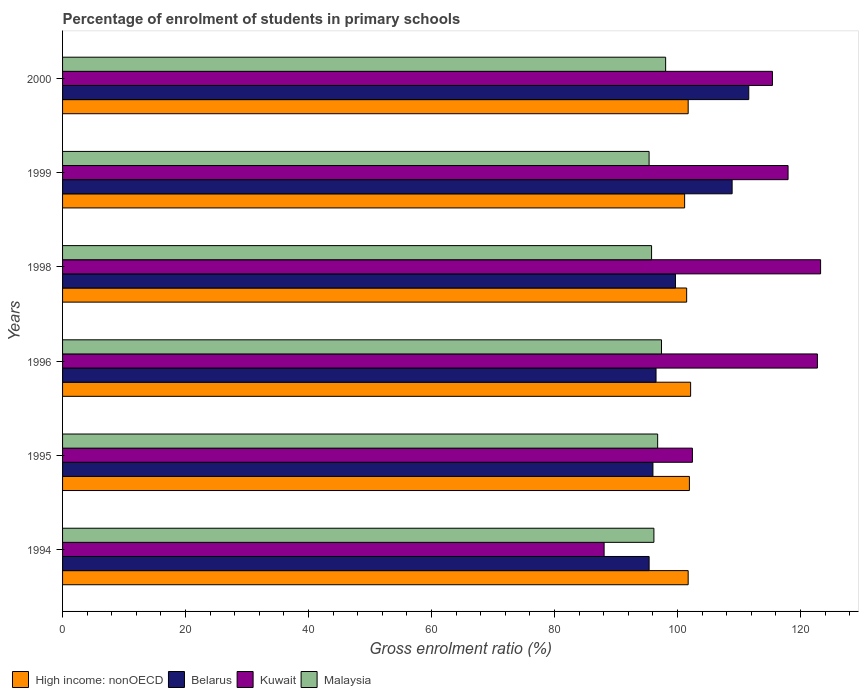How many groups of bars are there?
Your response must be concise. 6. Are the number of bars per tick equal to the number of legend labels?
Make the answer very short. Yes. Are the number of bars on each tick of the Y-axis equal?
Offer a very short reply. Yes. How many bars are there on the 3rd tick from the top?
Your answer should be very brief. 4. What is the label of the 1st group of bars from the top?
Keep it short and to the point. 2000. What is the percentage of students enrolled in primary schools in Malaysia in 1995?
Offer a very short reply. 96.78. Across all years, what is the maximum percentage of students enrolled in primary schools in Kuwait?
Provide a succinct answer. 123.28. Across all years, what is the minimum percentage of students enrolled in primary schools in High income: nonOECD?
Give a very brief answer. 101.16. What is the total percentage of students enrolled in primary schools in Belarus in the graph?
Your answer should be compact. 608.08. What is the difference between the percentage of students enrolled in primary schools in Belarus in 1996 and that in 1998?
Ensure brevity in your answer.  -3.16. What is the difference between the percentage of students enrolled in primary schools in Belarus in 1994 and the percentage of students enrolled in primary schools in Kuwait in 2000?
Your answer should be very brief. -20.05. What is the average percentage of students enrolled in primary schools in Belarus per year?
Offer a very short reply. 101.35. In the year 2000, what is the difference between the percentage of students enrolled in primary schools in High income: nonOECD and percentage of students enrolled in primary schools in Kuwait?
Ensure brevity in your answer.  -13.7. In how many years, is the percentage of students enrolled in primary schools in Malaysia greater than 80 %?
Your response must be concise. 6. What is the ratio of the percentage of students enrolled in primary schools in Belarus in 1998 to that in 1999?
Offer a terse response. 0.92. Is the percentage of students enrolled in primary schools in Malaysia in 1998 less than that in 2000?
Your answer should be compact. Yes. What is the difference between the highest and the second highest percentage of students enrolled in primary schools in Malaysia?
Provide a succinct answer. 0.67. What is the difference between the highest and the lowest percentage of students enrolled in primary schools in Kuwait?
Your answer should be compact. 35.21. In how many years, is the percentage of students enrolled in primary schools in Belarus greater than the average percentage of students enrolled in primary schools in Belarus taken over all years?
Offer a very short reply. 2. Is the sum of the percentage of students enrolled in primary schools in Kuwait in 1994 and 1995 greater than the maximum percentage of students enrolled in primary schools in Belarus across all years?
Your answer should be very brief. Yes. Is it the case that in every year, the sum of the percentage of students enrolled in primary schools in Malaysia and percentage of students enrolled in primary schools in Belarus is greater than the sum of percentage of students enrolled in primary schools in Kuwait and percentage of students enrolled in primary schools in High income: nonOECD?
Make the answer very short. No. What does the 3rd bar from the top in 1994 represents?
Provide a succinct answer. Belarus. What does the 4th bar from the bottom in 1998 represents?
Your answer should be compact. Malaysia. How many bars are there?
Make the answer very short. 24. How many years are there in the graph?
Provide a short and direct response. 6. Does the graph contain any zero values?
Give a very brief answer. No. Does the graph contain grids?
Make the answer very short. No. What is the title of the graph?
Ensure brevity in your answer.  Percentage of enrolment of students in primary schools. What is the label or title of the Y-axis?
Offer a terse response. Years. What is the Gross enrolment ratio (%) in High income: nonOECD in 1994?
Give a very brief answer. 101.74. What is the Gross enrolment ratio (%) in Belarus in 1994?
Offer a very short reply. 95.39. What is the Gross enrolment ratio (%) in Kuwait in 1994?
Ensure brevity in your answer.  88.07. What is the Gross enrolment ratio (%) of Malaysia in 1994?
Offer a terse response. 96.17. What is the Gross enrolment ratio (%) of High income: nonOECD in 1995?
Offer a very short reply. 101.94. What is the Gross enrolment ratio (%) of Belarus in 1995?
Offer a terse response. 96.01. What is the Gross enrolment ratio (%) in Kuwait in 1995?
Your answer should be very brief. 102.43. What is the Gross enrolment ratio (%) of Malaysia in 1995?
Your answer should be compact. 96.78. What is the Gross enrolment ratio (%) in High income: nonOECD in 1996?
Provide a succinct answer. 102.14. What is the Gross enrolment ratio (%) in Belarus in 1996?
Offer a terse response. 96.51. What is the Gross enrolment ratio (%) of Kuwait in 1996?
Your answer should be very brief. 122.76. What is the Gross enrolment ratio (%) of Malaysia in 1996?
Ensure brevity in your answer.  97.4. What is the Gross enrolment ratio (%) in High income: nonOECD in 1998?
Your answer should be compact. 101.5. What is the Gross enrolment ratio (%) of Belarus in 1998?
Your answer should be very brief. 99.68. What is the Gross enrolment ratio (%) of Kuwait in 1998?
Give a very brief answer. 123.28. What is the Gross enrolment ratio (%) of Malaysia in 1998?
Your response must be concise. 95.79. What is the Gross enrolment ratio (%) in High income: nonOECD in 1999?
Your answer should be compact. 101.16. What is the Gross enrolment ratio (%) of Belarus in 1999?
Your response must be concise. 108.89. What is the Gross enrolment ratio (%) of Kuwait in 1999?
Provide a short and direct response. 117.99. What is the Gross enrolment ratio (%) of Malaysia in 1999?
Your answer should be very brief. 95.39. What is the Gross enrolment ratio (%) of High income: nonOECD in 2000?
Offer a very short reply. 101.74. What is the Gross enrolment ratio (%) of Belarus in 2000?
Your answer should be compact. 111.6. What is the Gross enrolment ratio (%) of Kuwait in 2000?
Provide a short and direct response. 115.45. What is the Gross enrolment ratio (%) in Malaysia in 2000?
Provide a succinct answer. 98.08. Across all years, what is the maximum Gross enrolment ratio (%) of High income: nonOECD?
Ensure brevity in your answer.  102.14. Across all years, what is the maximum Gross enrolment ratio (%) in Belarus?
Offer a very short reply. 111.6. Across all years, what is the maximum Gross enrolment ratio (%) in Kuwait?
Offer a terse response. 123.28. Across all years, what is the maximum Gross enrolment ratio (%) in Malaysia?
Keep it short and to the point. 98.08. Across all years, what is the minimum Gross enrolment ratio (%) in High income: nonOECD?
Ensure brevity in your answer.  101.16. Across all years, what is the minimum Gross enrolment ratio (%) in Belarus?
Give a very brief answer. 95.39. Across all years, what is the minimum Gross enrolment ratio (%) in Kuwait?
Your answer should be compact. 88.07. Across all years, what is the minimum Gross enrolment ratio (%) of Malaysia?
Provide a succinct answer. 95.39. What is the total Gross enrolment ratio (%) of High income: nonOECD in the graph?
Provide a short and direct response. 610.23. What is the total Gross enrolment ratio (%) in Belarus in the graph?
Your answer should be very brief. 608.08. What is the total Gross enrolment ratio (%) in Kuwait in the graph?
Your answer should be very brief. 669.97. What is the total Gross enrolment ratio (%) of Malaysia in the graph?
Give a very brief answer. 579.6. What is the difference between the Gross enrolment ratio (%) in High income: nonOECD in 1994 and that in 1995?
Offer a very short reply. -0.2. What is the difference between the Gross enrolment ratio (%) in Belarus in 1994 and that in 1995?
Ensure brevity in your answer.  -0.62. What is the difference between the Gross enrolment ratio (%) of Kuwait in 1994 and that in 1995?
Your response must be concise. -14.36. What is the difference between the Gross enrolment ratio (%) in Malaysia in 1994 and that in 1995?
Give a very brief answer. -0.61. What is the difference between the Gross enrolment ratio (%) of High income: nonOECD in 1994 and that in 1996?
Provide a short and direct response. -0.4. What is the difference between the Gross enrolment ratio (%) in Belarus in 1994 and that in 1996?
Provide a short and direct response. -1.12. What is the difference between the Gross enrolment ratio (%) in Kuwait in 1994 and that in 1996?
Offer a very short reply. -34.69. What is the difference between the Gross enrolment ratio (%) in Malaysia in 1994 and that in 1996?
Provide a succinct answer. -1.23. What is the difference between the Gross enrolment ratio (%) in High income: nonOECD in 1994 and that in 1998?
Provide a short and direct response. 0.25. What is the difference between the Gross enrolment ratio (%) in Belarus in 1994 and that in 1998?
Your response must be concise. -4.29. What is the difference between the Gross enrolment ratio (%) in Kuwait in 1994 and that in 1998?
Provide a succinct answer. -35.21. What is the difference between the Gross enrolment ratio (%) of Malaysia in 1994 and that in 1998?
Offer a very short reply. 0.38. What is the difference between the Gross enrolment ratio (%) in High income: nonOECD in 1994 and that in 1999?
Your answer should be compact. 0.58. What is the difference between the Gross enrolment ratio (%) in Belarus in 1994 and that in 1999?
Your answer should be compact. -13.5. What is the difference between the Gross enrolment ratio (%) of Kuwait in 1994 and that in 1999?
Your response must be concise. -29.92. What is the difference between the Gross enrolment ratio (%) in Malaysia in 1994 and that in 1999?
Offer a very short reply. 0.78. What is the difference between the Gross enrolment ratio (%) in High income: nonOECD in 1994 and that in 2000?
Provide a short and direct response. 0. What is the difference between the Gross enrolment ratio (%) in Belarus in 1994 and that in 2000?
Offer a very short reply. -16.2. What is the difference between the Gross enrolment ratio (%) in Kuwait in 1994 and that in 2000?
Give a very brief answer. -27.38. What is the difference between the Gross enrolment ratio (%) of Malaysia in 1994 and that in 2000?
Your answer should be compact. -1.91. What is the difference between the Gross enrolment ratio (%) in High income: nonOECD in 1995 and that in 1996?
Offer a terse response. -0.2. What is the difference between the Gross enrolment ratio (%) in Belarus in 1995 and that in 1996?
Ensure brevity in your answer.  -0.5. What is the difference between the Gross enrolment ratio (%) of Kuwait in 1995 and that in 1996?
Provide a short and direct response. -20.33. What is the difference between the Gross enrolment ratio (%) of Malaysia in 1995 and that in 1996?
Your response must be concise. -0.62. What is the difference between the Gross enrolment ratio (%) in High income: nonOECD in 1995 and that in 1998?
Your response must be concise. 0.45. What is the difference between the Gross enrolment ratio (%) of Belarus in 1995 and that in 1998?
Give a very brief answer. -3.67. What is the difference between the Gross enrolment ratio (%) in Kuwait in 1995 and that in 1998?
Give a very brief answer. -20.85. What is the difference between the Gross enrolment ratio (%) in Malaysia in 1995 and that in 1998?
Keep it short and to the point. 0.99. What is the difference between the Gross enrolment ratio (%) of High income: nonOECD in 1995 and that in 1999?
Give a very brief answer. 0.78. What is the difference between the Gross enrolment ratio (%) in Belarus in 1995 and that in 1999?
Offer a very short reply. -12.88. What is the difference between the Gross enrolment ratio (%) of Kuwait in 1995 and that in 1999?
Offer a very short reply. -15.56. What is the difference between the Gross enrolment ratio (%) of Malaysia in 1995 and that in 1999?
Offer a very short reply. 1.39. What is the difference between the Gross enrolment ratio (%) of High income: nonOECD in 1995 and that in 2000?
Make the answer very short. 0.2. What is the difference between the Gross enrolment ratio (%) of Belarus in 1995 and that in 2000?
Offer a terse response. -15.58. What is the difference between the Gross enrolment ratio (%) of Kuwait in 1995 and that in 2000?
Keep it short and to the point. -13.01. What is the difference between the Gross enrolment ratio (%) in Malaysia in 1995 and that in 2000?
Provide a succinct answer. -1.3. What is the difference between the Gross enrolment ratio (%) of High income: nonOECD in 1996 and that in 1998?
Your answer should be very brief. 0.65. What is the difference between the Gross enrolment ratio (%) of Belarus in 1996 and that in 1998?
Make the answer very short. -3.16. What is the difference between the Gross enrolment ratio (%) in Kuwait in 1996 and that in 1998?
Give a very brief answer. -0.52. What is the difference between the Gross enrolment ratio (%) of Malaysia in 1996 and that in 1998?
Provide a succinct answer. 1.61. What is the difference between the Gross enrolment ratio (%) in High income: nonOECD in 1996 and that in 1999?
Provide a succinct answer. 0.98. What is the difference between the Gross enrolment ratio (%) of Belarus in 1996 and that in 1999?
Offer a terse response. -12.38. What is the difference between the Gross enrolment ratio (%) of Kuwait in 1996 and that in 1999?
Give a very brief answer. 4.77. What is the difference between the Gross enrolment ratio (%) in Malaysia in 1996 and that in 1999?
Ensure brevity in your answer.  2.02. What is the difference between the Gross enrolment ratio (%) of High income: nonOECD in 1996 and that in 2000?
Offer a very short reply. 0.4. What is the difference between the Gross enrolment ratio (%) of Belarus in 1996 and that in 2000?
Ensure brevity in your answer.  -15.08. What is the difference between the Gross enrolment ratio (%) of Kuwait in 1996 and that in 2000?
Offer a very short reply. 7.31. What is the difference between the Gross enrolment ratio (%) of Malaysia in 1996 and that in 2000?
Provide a succinct answer. -0.67. What is the difference between the Gross enrolment ratio (%) in High income: nonOECD in 1998 and that in 1999?
Ensure brevity in your answer.  0.33. What is the difference between the Gross enrolment ratio (%) of Belarus in 1998 and that in 1999?
Your response must be concise. -9.21. What is the difference between the Gross enrolment ratio (%) of Kuwait in 1998 and that in 1999?
Provide a short and direct response. 5.29. What is the difference between the Gross enrolment ratio (%) in Malaysia in 1998 and that in 1999?
Offer a terse response. 0.4. What is the difference between the Gross enrolment ratio (%) in High income: nonOECD in 1998 and that in 2000?
Your response must be concise. -0.25. What is the difference between the Gross enrolment ratio (%) of Belarus in 1998 and that in 2000?
Make the answer very short. -11.92. What is the difference between the Gross enrolment ratio (%) in Kuwait in 1998 and that in 2000?
Provide a succinct answer. 7.83. What is the difference between the Gross enrolment ratio (%) of Malaysia in 1998 and that in 2000?
Provide a succinct answer. -2.29. What is the difference between the Gross enrolment ratio (%) in High income: nonOECD in 1999 and that in 2000?
Your answer should be compact. -0.58. What is the difference between the Gross enrolment ratio (%) of Belarus in 1999 and that in 2000?
Your answer should be compact. -2.71. What is the difference between the Gross enrolment ratio (%) of Kuwait in 1999 and that in 2000?
Make the answer very short. 2.54. What is the difference between the Gross enrolment ratio (%) of Malaysia in 1999 and that in 2000?
Keep it short and to the point. -2.69. What is the difference between the Gross enrolment ratio (%) in High income: nonOECD in 1994 and the Gross enrolment ratio (%) in Belarus in 1995?
Keep it short and to the point. 5.73. What is the difference between the Gross enrolment ratio (%) in High income: nonOECD in 1994 and the Gross enrolment ratio (%) in Kuwait in 1995?
Your answer should be very brief. -0.69. What is the difference between the Gross enrolment ratio (%) of High income: nonOECD in 1994 and the Gross enrolment ratio (%) of Malaysia in 1995?
Offer a very short reply. 4.96. What is the difference between the Gross enrolment ratio (%) in Belarus in 1994 and the Gross enrolment ratio (%) in Kuwait in 1995?
Ensure brevity in your answer.  -7.04. What is the difference between the Gross enrolment ratio (%) of Belarus in 1994 and the Gross enrolment ratio (%) of Malaysia in 1995?
Provide a succinct answer. -1.39. What is the difference between the Gross enrolment ratio (%) of Kuwait in 1994 and the Gross enrolment ratio (%) of Malaysia in 1995?
Provide a short and direct response. -8.71. What is the difference between the Gross enrolment ratio (%) of High income: nonOECD in 1994 and the Gross enrolment ratio (%) of Belarus in 1996?
Your answer should be very brief. 5.23. What is the difference between the Gross enrolment ratio (%) of High income: nonOECD in 1994 and the Gross enrolment ratio (%) of Kuwait in 1996?
Your answer should be very brief. -21.02. What is the difference between the Gross enrolment ratio (%) in High income: nonOECD in 1994 and the Gross enrolment ratio (%) in Malaysia in 1996?
Provide a short and direct response. 4.34. What is the difference between the Gross enrolment ratio (%) in Belarus in 1994 and the Gross enrolment ratio (%) in Kuwait in 1996?
Your answer should be very brief. -27.37. What is the difference between the Gross enrolment ratio (%) in Belarus in 1994 and the Gross enrolment ratio (%) in Malaysia in 1996?
Keep it short and to the point. -2.01. What is the difference between the Gross enrolment ratio (%) in Kuwait in 1994 and the Gross enrolment ratio (%) in Malaysia in 1996?
Your answer should be very brief. -9.33. What is the difference between the Gross enrolment ratio (%) in High income: nonOECD in 1994 and the Gross enrolment ratio (%) in Belarus in 1998?
Keep it short and to the point. 2.06. What is the difference between the Gross enrolment ratio (%) of High income: nonOECD in 1994 and the Gross enrolment ratio (%) of Kuwait in 1998?
Offer a terse response. -21.53. What is the difference between the Gross enrolment ratio (%) in High income: nonOECD in 1994 and the Gross enrolment ratio (%) in Malaysia in 1998?
Provide a succinct answer. 5.95. What is the difference between the Gross enrolment ratio (%) in Belarus in 1994 and the Gross enrolment ratio (%) in Kuwait in 1998?
Ensure brevity in your answer.  -27.89. What is the difference between the Gross enrolment ratio (%) of Belarus in 1994 and the Gross enrolment ratio (%) of Malaysia in 1998?
Make the answer very short. -0.4. What is the difference between the Gross enrolment ratio (%) in Kuwait in 1994 and the Gross enrolment ratio (%) in Malaysia in 1998?
Provide a succinct answer. -7.72. What is the difference between the Gross enrolment ratio (%) of High income: nonOECD in 1994 and the Gross enrolment ratio (%) of Belarus in 1999?
Ensure brevity in your answer.  -7.15. What is the difference between the Gross enrolment ratio (%) of High income: nonOECD in 1994 and the Gross enrolment ratio (%) of Kuwait in 1999?
Make the answer very short. -16.25. What is the difference between the Gross enrolment ratio (%) of High income: nonOECD in 1994 and the Gross enrolment ratio (%) of Malaysia in 1999?
Provide a succinct answer. 6.36. What is the difference between the Gross enrolment ratio (%) of Belarus in 1994 and the Gross enrolment ratio (%) of Kuwait in 1999?
Give a very brief answer. -22.6. What is the difference between the Gross enrolment ratio (%) in Belarus in 1994 and the Gross enrolment ratio (%) in Malaysia in 1999?
Keep it short and to the point. 0.01. What is the difference between the Gross enrolment ratio (%) of Kuwait in 1994 and the Gross enrolment ratio (%) of Malaysia in 1999?
Make the answer very short. -7.32. What is the difference between the Gross enrolment ratio (%) of High income: nonOECD in 1994 and the Gross enrolment ratio (%) of Belarus in 2000?
Give a very brief answer. -9.85. What is the difference between the Gross enrolment ratio (%) of High income: nonOECD in 1994 and the Gross enrolment ratio (%) of Kuwait in 2000?
Offer a terse response. -13.7. What is the difference between the Gross enrolment ratio (%) of High income: nonOECD in 1994 and the Gross enrolment ratio (%) of Malaysia in 2000?
Your answer should be very brief. 3.67. What is the difference between the Gross enrolment ratio (%) in Belarus in 1994 and the Gross enrolment ratio (%) in Kuwait in 2000?
Offer a terse response. -20.05. What is the difference between the Gross enrolment ratio (%) in Belarus in 1994 and the Gross enrolment ratio (%) in Malaysia in 2000?
Ensure brevity in your answer.  -2.69. What is the difference between the Gross enrolment ratio (%) of Kuwait in 1994 and the Gross enrolment ratio (%) of Malaysia in 2000?
Keep it short and to the point. -10.01. What is the difference between the Gross enrolment ratio (%) of High income: nonOECD in 1995 and the Gross enrolment ratio (%) of Belarus in 1996?
Offer a very short reply. 5.43. What is the difference between the Gross enrolment ratio (%) in High income: nonOECD in 1995 and the Gross enrolment ratio (%) in Kuwait in 1996?
Make the answer very short. -20.82. What is the difference between the Gross enrolment ratio (%) in High income: nonOECD in 1995 and the Gross enrolment ratio (%) in Malaysia in 1996?
Your answer should be compact. 4.54. What is the difference between the Gross enrolment ratio (%) in Belarus in 1995 and the Gross enrolment ratio (%) in Kuwait in 1996?
Provide a short and direct response. -26.75. What is the difference between the Gross enrolment ratio (%) of Belarus in 1995 and the Gross enrolment ratio (%) of Malaysia in 1996?
Offer a terse response. -1.39. What is the difference between the Gross enrolment ratio (%) of Kuwait in 1995 and the Gross enrolment ratio (%) of Malaysia in 1996?
Provide a succinct answer. 5.03. What is the difference between the Gross enrolment ratio (%) of High income: nonOECD in 1995 and the Gross enrolment ratio (%) of Belarus in 1998?
Your answer should be compact. 2.26. What is the difference between the Gross enrolment ratio (%) of High income: nonOECD in 1995 and the Gross enrolment ratio (%) of Kuwait in 1998?
Your answer should be very brief. -21.33. What is the difference between the Gross enrolment ratio (%) of High income: nonOECD in 1995 and the Gross enrolment ratio (%) of Malaysia in 1998?
Your answer should be very brief. 6.15. What is the difference between the Gross enrolment ratio (%) of Belarus in 1995 and the Gross enrolment ratio (%) of Kuwait in 1998?
Ensure brevity in your answer.  -27.26. What is the difference between the Gross enrolment ratio (%) of Belarus in 1995 and the Gross enrolment ratio (%) of Malaysia in 1998?
Your response must be concise. 0.22. What is the difference between the Gross enrolment ratio (%) in Kuwait in 1995 and the Gross enrolment ratio (%) in Malaysia in 1998?
Offer a terse response. 6.64. What is the difference between the Gross enrolment ratio (%) of High income: nonOECD in 1995 and the Gross enrolment ratio (%) of Belarus in 1999?
Your answer should be compact. -6.95. What is the difference between the Gross enrolment ratio (%) of High income: nonOECD in 1995 and the Gross enrolment ratio (%) of Kuwait in 1999?
Make the answer very short. -16.05. What is the difference between the Gross enrolment ratio (%) in High income: nonOECD in 1995 and the Gross enrolment ratio (%) in Malaysia in 1999?
Your response must be concise. 6.56. What is the difference between the Gross enrolment ratio (%) of Belarus in 1995 and the Gross enrolment ratio (%) of Kuwait in 1999?
Provide a short and direct response. -21.98. What is the difference between the Gross enrolment ratio (%) of Belarus in 1995 and the Gross enrolment ratio (%) of Malaysia in 1999?
Provide a succinct answer. 0.63. What is the difference between the Gross enrolment ratio (%) in Kuwait in 1995 and the Gross enrolment ratio (%) in Malaysia in 1999?
Ensure brevity in your answer.  7.05. What is the difference between the Gross enrolment ratio (%) in High income: nonOECD in 1995 and the Gross enrolment ratio (%) in Belarus in 2000?
Ensure brevity in your answer.  -9.65. What is the difference between the Gross enrolment ratio (%) in High income: nonOECD in 1995 and the Gross enrolment ratio (%) in Kuwait in 2000?
Offer a very short reply. -13.5. What is the difference between the Gross enrolment ratio (%) in High income: nonOECD in 1995 and the Gross enrolment ratio (%) in Malaysia in 2000?
Your response must be concise. 3.87. What is the difference between the Gross enrolment ratio (%) of Belarus in 1995 and the Gross enrolment ratio (%) of Kuwait in 2000?
Give a very brief answer. -19.43. What is the difference between the Gross enrolment ratio (%) of Belarus in 1995 and the Gross enrolment ratio (%) of Malaysia in 2000?
Your answer should be very brief. -2.06. What is the difference between the Gross enrolment ratio (%) of Kuwait in 1995 and the Gross enrolment ratio (%) of Malaysia in 2000?
Give a very brief answer. 4.35. What is the difference between the Gross enrolment ratio (%) of High income: nonOECD in 1996 and the Gross enrolment ratio (%) of Belarus in 1998?
Give a very brief answer. 2.46. What is the difference between the Gross enrolment ratio (%) in High income: nonOECD in 1996 and the Gross enrolment ratio (%) in Kuwait in 1998?
Give a very brief answer. -21.14. What is the difference between the Gross enrolment ratio (%) of High income: nonOECD in 1996 and the Gross enrolment ratio (%) of Malaysia in 1998?
Make the answer very short. 6.35. What is the difference between the Gross enrolment ratio (%) in Belarus in 1996 and the Gross enrolment ratio (%) in Kuwait in 1998?
Your answer should be very brief. -26.76. What is the difference between the Gross enrolment ratio (%) of Belarus in 1996 and the Gross enrolment ratio (%) of Malaysia in 1998?
Your response must be concise. 0.72. What is the difference between the Gross enrolment ratio (%) of Kuwait in 1996 and the Gross enrolment ratio (%) of Malaysia in 1998?
Your answer should be very brief. 26.97. What is the difference between the Gross enrolment ratio (%) in High income: nonOECD in 1996 and the Gross enrolment ratio (%) in Belarus in 1999?
Offer a terse response. -6.75. What is the difference between the Gross enrolment ratio (%) of High income: nonOECD in 1996 and the Gross enrolment ratio (%) of Kuwait in 1999?
Make the answer very short. -15.85. What is the difference between the Gross enrolment ratio (%) of High income: nonOECD in 1996 and the Gross enrolment ratio (%) of Malaysia in 1999?
Offer a terse response. 6.76. What is the difference between the Gross enrolment ratio (%) in Belarus in 1996 and the Gross enrolment ratio (%) in Kuwait in 1999?
Your answer should be very brief. -21.47. What is the difference between the Gross enrolment ratio (%) of Belarus in 1996 and the Gross enrolment ratio (%) of Malaysia in 1999?
Offer a terse response. 1.13. What is the difference between the Gross enrolment ratio (%) in Kuwait in 1996 and the Gross enrolment ratio (%) in Malaysia in 1999?
Offer a terse response. 27.37. What is the difference between the Gross enrolment ratio (%) in High income: nonOECD in 1996 and the Gross enrolment ratio (%) in Belarus in 2000?
Give a very brief answer. -9.45. What is the difference between the Gross enrolment ratio (%) in High income: nonOECD in 1996 and the Gross enrolment ratio (%) in Kuwait in 2000?
Your response must be concise. -13.3. What is the difference between the Gross enrolment ratio (%) in High income: nonOECD in 1996 and the Gross enrolment ratio (%) in Malaysia in 2000?
Provide a succinct answer. 4.06. What is the difference between the Gross enrolment ratio (%) of Belarus in 1996 and the Gross enrolment ratio (%) of Kuwait in 2000?
Offer a very short reply. -18.93. What is the difference between the Gross enrolment ratio (%) in Belarus in 1996 and the Gross enrolment ratio (%) in Malaysia in 2000?
Your response must be concise. -1.56. What is the difference between the Gross enrolment ratio (%) of Kuwait in 1996 and the Gross enrolment ratio (%) of Malaysia in 2000?
Ensure brevity in your answer.  24.68. What is the difference between the Gross enrolment ratio (%) of High income: nonOECD in 1998 and the Gross enrolment ratio (%) of Belarus in 1999?
Provide a short and direct response. -7.39. What is the difference between the Gross enrolment ratio (%) of High income: nonOECD in 1998 and the Gross enrolment ratio (%) of Kuwait in 1999?
Give a very brief answer. -16.49. What is the difference between the Gross enrolment ratio (%) of High income: nonOECD in 1998 and the Gross enrolment ratio (%) of Malaysia in 1999?
Your answer should be very brief. 6.11. What is the difference between the Gross enrolment ratio (%) of Belarus in 1998 and the Gross enrolment ratio (%) of Kuwait in 1999?
Ensure brevity in your answer.  -18.31. What is the difference between the Gross enrolment ratio (%) of Belarus in 1998 and the Gross enrolment ratio (%) of Malaysia in 1999?
Your answer should be compact. 4.29. What is the difference between the Gross enrolment ratio (%) in Kuwait in 1998 and the Gross enrolment ratio (%) in Malaysia in 1999?
Ensure brevity in your answer.  27.89. What is the difference between the Gross enrolment ratio (%) of High income: nonOECD in 1998 and the Gross enrolment ratio (%) of Belarus in 2000?
Offer a terse response. -10.1. What is the difference between the Gross enrolment ratio (%) of High income: nonOECD in 1998 and the Gross enrolment ratio (%) of Kuwait in 2000?
Provide a succinct answer. -13.95. What is the difference between the Gross enrolment ratio (%) in High income: nonOECD in 1998 and the Gross enrolment ratio (%) in Malaysia in 2000?
Your answer should be very brief. 3.42. What is the difference between the Gross enrolment ratio (%) of Belarus in 1998 and the Gross enrolment ratio (%) of Kuwait in 2000?
Make the answer very short. -15.77. What is the difference between the Gross enrolment ratio (%) in Belarus in 1998 and the Gross enrolment ratio (%) in Malaysia in 2000?
Ensure brevity in your answer.  1.6. What is the difference between the Gross enrolment ratio (%) of Kuwait in 1998 and the Gross enrolment ratio (%) of Malaysia in 2000?
Give a very brief answer. 25.2. What is the difference between the Gross enrolment ratio (%) in High income: nonOECD in 1999 and the Gross enrolment ratio (%) in Belarus in 2000?
Ensure brevity in your answer.  -10.43. What is the difference between the Gross enrolment ratio (%) in High income: nonOECD in 1999 and the Gross enrolment ratio (%) in Kuwait in 2000?
Keep it short and to the point. -14.28. What is the difference between the Gross enrolment ratio (%) in High income: nonOECD in 1999 and the Gross enrolment ratio (%) in Malaysia in 2000?
Offer a terse response. 3.09. What is the difference between the Gross enrolment ratio (%) in Belarus in 1999 and the Gross enrolment ratio (%) in Kuwait in 2000?
Your answer should be compact. -6.56. What is the difference between the Gross enrolment ratio (%) in Belarus in 1999 and the Gross enrolment ratio (%) in Malaysia in 2000?
Ensure brevity in your answer.  10.81. What is the difference between the Gross enrolment ratio (%) in Kuwait in 1999 and the Gross enrolment ratio (%) in Malaysia in 2000?
Your answer should be compact. 19.91. What is the average Gross enrolment ratio (%) in High income: nonOECD per year?
Provide a succinct answer. 101.7. What is the average Gross enrolment ratio (%) in Belarus per year?
Your response must be concise. 101.35. What is the average Gross enrolment ratio (%) of Kuwait per year?
Offer a very short reply. 111.66. What is the average Gross enrolment ratio (%) in Malaysia per year?
Ensure brevity in your answer.  96.6. In the year 1994, what is the difference between the Gross enrolment ratio (%) in High income: nonOECD and Gross enrolment ratio (%) in Belarus?
Your response must be concise. 6.35. In the year 1994, what is the difference between the Gross enrolment ratio (%) in High income: nonOECD and Gross enrolment ratio (%) in Kuwait?
Keep it short and to the point. 13.67. In the year 1994, what is the difference between the Gross enrolment ratio (%) in High income: nonOECD and Gross enrolment ratio (%) in Malaysia?
Provide a short and direct response. 5.57. In the year 1994, what is the difference between the Gross enrolment ratio (%) in Belarus and Gross enrolment ratio (%) in Kuwait?
Your response must be concise. 7.32. In the year 1994, what is the difference between the Gross enrolment ratio (%) of Belarus and Gross enrolment ratio (%) of Malaysia?
Ensure brevity in your answer.  -0.78. In the year 1994, what is the difference between the Gross enrolment ratio (%) of Kuwait and Gross enrolment ratio (%) of Malaysia?
Offer a very short reply. -8.1. In the year 1995, what is the difference between the Gross enrolment ratio (%) of High income: nonOECD and Gross enrolment ratio (%) of Belarus?
Offer a very short reply. 5.93. In the year 1995, what is the difference between the Gross enrolment ratio (%) in High income: nonOECD and Gross enrolment ratio (%) in Kuwait?
Offer a terse response. -0.49. In the year 1995, what is the difference between the Gross enrolment ratio (%) of High income: nonOECD and Gross enrolment ratio (%) of Malaysia?
Make the answer very short. 5.16. In the year 1995, what is the difference between the Gross enrolment ratio (%) in Belarus and Gross enrolment ratio (%) in Kuwait?
Give a very brief answer. -6.42. In the year 1995, what is the difference between the Gross enrolment ratio (%) in Belarus and Gross enrolment ratio (%) in Malaysia?
Your answer should be compact. -0.77. In the year 1995, what is the difference between the Gross enrolment ratio (%) of Kuwait and Gross enrolment ratio (%) of Malaysia?
Keep it short and to the point. 5.65. In the year 1996, what is the difference between the Gross enrolment ratio (%) in High income: nonOECD and Gross enrolment ratio (%) in Belarus?
Your answer should be compact. 5.63. In the year 1996, what is the difference between the Gross enrolment ratio (%) in High income: nonOECD and Gross enrolment ratio (%) in Kuwait?
Your response must be concise. -20.62. In the year 1996, what is the difference between the Gross enrolment ratio (%) of High income: nonOECD and Gross enrolment ratio (%) of Malaysia?
Make the answer very short. 4.74. In the year 1996, what is the difference between the Gross enrolment ratio (%) of Belarus and Gross enrolment ratio (%) of Kuwait?
Offer a very short reply. -26.25. In the year 1996, what is the difference between the Gross enrolment ratio (%) in Belarus and Gross enrolment ratio (%) in Malaysia?
Provide a short and direct response. -0.89. In the year 1996, what is the difference between the Gross enrolment ratio (%) of Kuwait and Gross enrolment ratio (%) of Malaysia?
Ensure brevity in your answer.  25.36. In the year 1998, what is the difference between the Gross enrolment ratio (%) of High income: nonOECD and Gross enrolment ratio (%) of Belarus?
Offer a terse response. 1.82. In the year 1998, what is the difference between the Gross enrolment ratio (%) of High income: nonOECD and Gross enrolment ratio (%) of Kuwait?
Offer a terse response. -21.78. In the year 1998, what is the difference between the Gross enrolment ratio (%) in High income: nonOECD and Gross enrolment ratio (%) in Malaysia?
Keep it short and to the point. 5.71. In the year 1998, what is the difference between the Gross enrolment ratio (%) in Belarus and Gross enrolment ratio (%) in Kuwait?
Your answer should be compact. -23.6. In the year 1998, what is the difference between the Gross enrolment ratio (%) in Belarus and Gross enrolment ratio (%) in Malaysia?
Ensure brevity in your answer.  3.89. In the year 1998, what is the difference between the Gross enrolment ratio (%) in Kuwait and Gross enrolment ratio (%) in Malaysia?
Offer a very short reply. 27.49. In the year 1999, what is the difference between the Gross enrolment ratio (%) of High income: nonOECD and Gross enrolment ratio (%) of Belarus?
Your answer should be compact. -7.73. In the year 1999, what is the difference between the Gross enrolment ratio (%) of High income: nonOECD and Gross enrolment ratio (%) of Kuwait?
Give a very brief answer. -16.82. In the year 1999, what is the difference between the Gross enrolment ratio (%) in High income: nonOECD and Gross enrolment ratio (%) in Malaysia?
Your answer should be very brief. 5.78. In the year 1999, what is the difference between the Gross enrolment ratio (%) of Belarus and Gross enrolment ratio (%) of Kuwait?
Offer a terse response. -9.1. In the year 1999, what is the difference between the Gross enrolment ratio (%) in Belarus and Gross enrolment ratio (%) in Malaysia?
Ensure brevity in your answer.  13.5. In the year 1999, what is the difference between the Gross enrolment ratio (%) of Kuwait and Gross enrolment ratio (%) of Malaysia?
Offer a very short reply. 22.6. In the year 2000, what is the difference between the Gross enrolment ratio (%) of High income: nonOECD and Gross enrolment ratio (%) of Belarus?
Provide a short and direct response. -9.85. In the year 2000, what is the difference between the Gross enrolment ratio (%) of High income: nonOECD and Gross enrolment ratio (%) of Kuwait?
Offer a terse response. -13.7. In the year 2000, what is the difference between the Gross enrolment ratio (%) in High income: nonOECD and Gross enrolment ratio (%) in Malaysia?
Give a very brief answer. 3.67. In the year 2000, what is the difference between the Gross enrolment ratio (%) of Belarus and Gross enrolment ratio (%) of Kuwait?
Your response must be concise. -3.85. In the year 2000, what is the difference between the Gross enrolment ratio (%) of Belarus and Gross enrolment ratio (%) of Malaysia?
Offer a very short reply. 13.52. In the year 2000, what is the difference between the Gross enrolment ratio (%) in Kuwait and Gross enrolment ratio (%) in Malaysia?
Offer a terse response. 17.37. What is the ratio of the Gross enrolment ratio (%) in High income: nonOECD in 1994 to that in 1995?
Provide a short and direct response. 1. What is the ratio of the Gross enrolment ratio (%) in Kuwait in 1994 to that in 1995?
Give a very brief answer. 0.86. What is the ratio of the Gross enrolment ratio (%) of High income: nonOECD in 1994 to that in 1996?
Offer a terse response. 1. What is the ratio of the Gross enrolment ratio (%) in Belarus in 1994 to that in 1996?
Keep it short and to the point. 0.99. What is the ratio of the Gross enrolment ratio (%) of Kuwait in 1994 to that in 1996?
Provide a succinct answer. 0.72. What is the ratio of the Gross enrolment ratio (%) of Malaysia in 1994 to that in 1996?
Your answer should be compact. 0.99. What is the ratio of the Gross enrolment ratio (%) in Belarus in 1994 to that in 1998?
Offer a terse response. 0.96. What is the ratio of the Gross enrolment ratio (%) in Kuwait in 1994 to that in 1998?
Your answer should be very brief. 0.71. What is the ratio of the Gross enrolment ratio (%) in High income: nonOECD in 1994 to that in 1999?
Your answer should be compact. 1.01. What is the ratio of the Gross enrolment ratio (%) in Belarus in 1994 to that in 1999?
Your response must be concise. 0.88. What is the ratio of the Gross enrolment ratio (%) of Kuwait in 1994 to that in 1999?
Your response must be concise. 0.75. What is the ratio of the Gross enrolment ratio (%) in Malaysia in 1994 to that in 1999?
Keep it short and to the point. 1.01. What is the ratio of the Gross enrolment ratio (%) of High income: nonOECD in 1994 to that in 2000?
Ensure brevity in your answer.  1. What is the ratio of the Gross enrolment ratio (%) in Belarus in 1994 to that in 2000?
Your answer should be compact. 0.85. What is the ratio of the Gross enrolment ratio (%) of Kuwait in 1994 to that in 2000?
Offer a terse response. 0.76. What is the ratio of the Gross enrolment ratio (%) in Malaysia in 1994 to that in 2000?
Make the answer very short. 0.98. What is the ratio of the Gross enrolment ratio (%) of Belarus in 1995 to that in 1996?
Your answer should be very brief. 0.99. What is the ratio of the Gross enrolment ratio (%) of Kuwait in 1995 to that in 1996?
Provide a succinct answer. 0.83. What is the ratio of the Gross enrolment ratio (%) of High income: nonOECD in 1995 to that in 1998?
Offer a very short reply. 1. What is the ratio of the Gross enrolment ratio (%) in Belarus in 1995 to that in 1998?
Your answer should be compact. 0.96. What is the ratio of the Gross enrolment ratio (%) of Kuwait in 1995 to that in 1998?
Provide a succinct answer. 0.83. What is the ratio of the Gross enrolment ratio (%) of Malaysia in 1995 to that in 1998?
Your answer should be compact. 1.01. What is the ratio of the Gross enrolment ratio (%) of High income: nonOECD in 1995 to that in 1999?
Give a very brief answer. 1.01. What is the ratio of the Gross enrolment ratio (%) of Belarus in 1995 to that in 1999?
Make the answer very short. 0.88. What is the ratio of the Gross enrolment ratio (%) in Kuwait in 1995 to that in 1999?
Your answer should be compact. 0.87. What is the ratio of the Gross enrolment ratio (%) in Malaysia in 1995 to that in 1999?
Make the answer very short. 1.01. What is the ratio of the Gross enrolment ratio (%) in High income: nonOECD in 1995 to that in 2000?
Your answer should be very brief. 1. What is the ratio of the Gross enrolment ratio (%) of Belarus in 1995 to that in 2000?
Your answer should be compact. 0.86. What is the ratio of the Gross enrolment ratio (%) of Kuwait in 1995 to that in 2000?
Ensure brevity in your answer.  0.89. What is the ratio of the Gross enrolment ratio (%) of High income: nonOECD in 1996 to that in 1998?
Provide a succinct answer. 1.01. What is the ratio of the Gross enrolment ratio (%) of Belarus in 1996 to that in 1998?
Give a very brief answer. 0.97. What is the ratio of the Gross enrolment ratio (%) of Malaysia in 1996 to that in 1998?
Keep it short and to the point. 1.02. What is the ratio of the Gross enrolment ratio (%) of High income: nonOECD in 1996 to that in 1999?
Ensure brevity in your answer.  1.01. What is the ratio of the Gross enrolment ratio (%) in Belarus in 1996 to that in 1999?
Ensure brevity in your answer.  0.89. What is the ratio of the Gross enrolment ratio (%) of Kuwait in 1996 to that in 1999?
Ensure brevity in your answer.  1.04. What is the ratio of the Gross enrolment ratio (%) in Malaysia in 1996 to that in 1999?
Your answer should be very brief. 1.02. What is the ratio of the Gross enrolment ratio (%) in Belarus in 1996 to that in 2000?
Offer a terse response. 0.86. What is the ratio of the Gross enrolment ratio (%) of Kuwait in 1996 to that in 2000?
Your answer should be compact. 1.06. What is the ratio of the Gross enrolment ratio (%) in Belarus in 1998 to that in 1999?
Make the answer very short. 0.92. What is the ratio of the Gross enrolment ratio (%) in Kuwait in 1998 to that in 1999?
Provide a succinct answer. 1.04. What is the ratio of the Gross enrolment ratio (%) in Malaysia in 1998 to that in 1999?
Ensure brevity in your answer.  1. What is the ratio of the Gross enrolment ratio (%) in High income: nonOECD in 1998 to that in 2000?
Provide a succinct answer. 1. What is the ratio of the Gross enrolment ratio (%) in Belarus in 1998 to that in 2000?
Your answer should be compact. 0.89. What is the ratio of the Gross enrolment ratio (%) of Kuwait in 1998 to that in 2000?
Your response must be concise. 1.07. What is the ratio of the Gross enrolment ratio (%) in Malaysia in 1998 to that in 2000?
Offer a terse response. 0.98. What is the ratio of the Gross enrolment ratio (%) of Belarus in 1999 to that in 2000?
Your answer should be very brief. 0.98. What is the ratio of the Gross enrolment ratio (%) of Malaysia in 1999 to that in 2000?
Keep it short and to the point. 0.97. What is the difference between the highest and the second highest Gross enrolment ratio (%) in High income: nonOECD?
Provide a succinct answer. 0.2. What is the difference between the highest and the second highest Gross enrolment ratio (%) of Belarus?
Provide a succinct answer. 2.71. What is the difference between the highest and the second highest Gross enrolment ratio (%) of Kuwait?
Make the answer very short. 0.52. What is the difference between the highest and the second highest Gross enrolment ratio (%) of Malaysia?
Your answer should be very brief. 0.67. What is the difference between the highest and the lowest Gross enrolment ratio (%) of High income: nonOECD?
Your answer should be compact. 0.98. What is the difference between the highest and the lowest Gross enrolment ratio (%) in Belarus?
Offer a terse response. 16.2. What is the difference between the highest and the lowest Gross enrolment ratio (%) of Kuwait?
Provide a short and direct response. 35.21. What is the difference between the highest and the lowest Gross enrolment ratio (%) of Malaysia?
Provide a short and direct response. 2.69. 